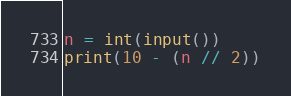Convert code to text. <code><loc_0><loc_0><loc_500><loc_500><_Python_>n = int(input())
print(10 - (n // 2))</code> 